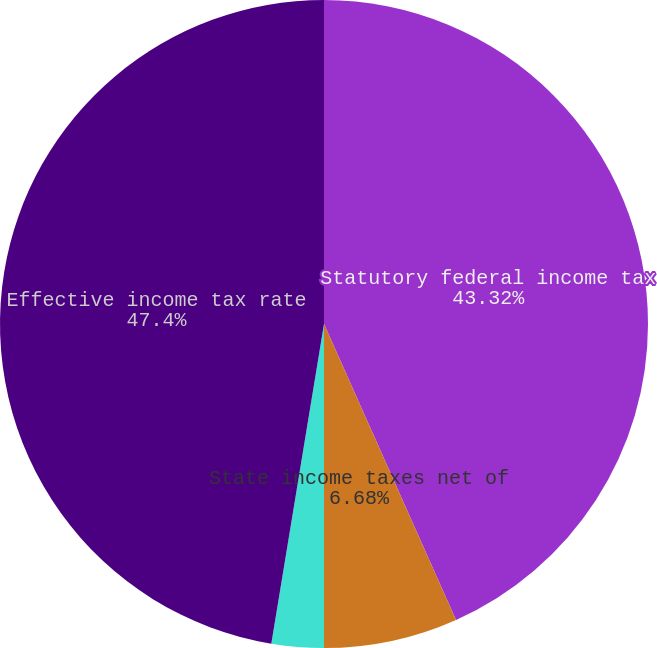<chart> <loc_0><loc_0><loc_500><loc_500><pie_chart><fcel>Statutory federal income tax<fcel>State income taxes net of<fcel>Other net<fcel>Effective income tax rate<nl><fcel>43.32%<fcel>6.68%<fcel>2.6%<fcel>47.4%<nl></chart> 